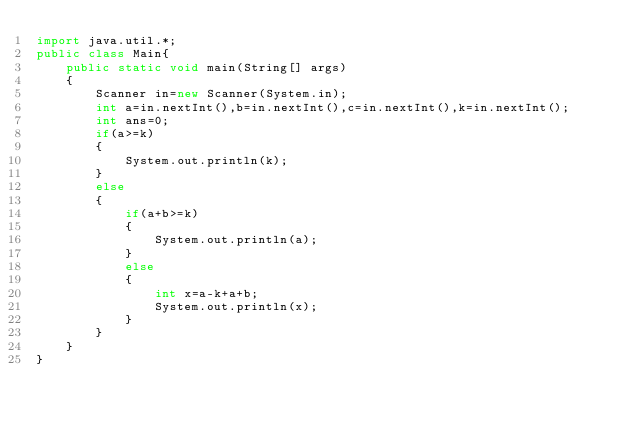<code> <loc_0><loc_0><loc_500><loc_500><_Java_>import java.util.*;
public class Main{
	public static void main(String[] args)
	{
		Scanner in=new Scanner(System.in);
		int a=in.nextInt(),b=in.nextInt(),c=in.nextInt(),k=in.nextInt();
		int ans=0;
		if(a>=k)
		{
			System.out.println(k);
		}
		else 
		{
			if(a+b>=k)
			{
				System.out.println(a);
			}
			else
			{
				int x=a-k+a+b;
				System.out.println(x);
			}
		}
	}
}</code> 